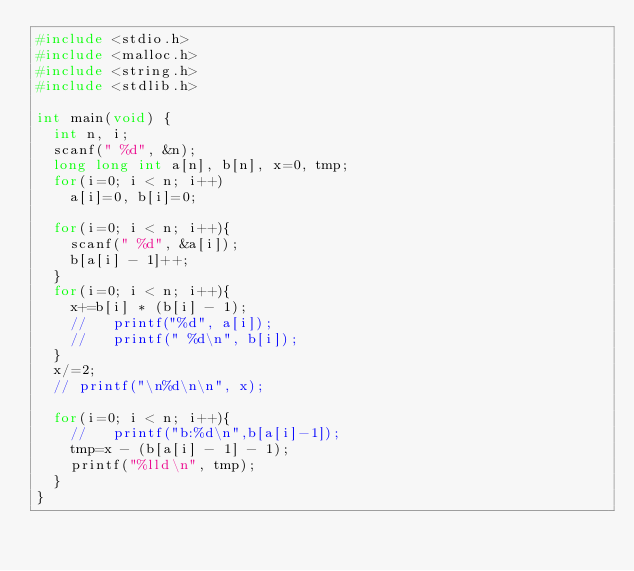Convert code to text. <code><loc_0><loc_0><loc_500><loc_500><_C_>#include <stdio.h>
#include <malloc.h>
#include <string.h>
#include <stdlib.h>

int main(void) {
  int n, i;
  scanf(" %d", &n);
  long long int a[n], b[n], x=0, tmp;
  for(i=0; i < n; i++)
    a[i]=0, b[i]=0;

  for(i=0; i < n; i++){
    scanf(" %d", &a[i]);
    b[a[i] - 1]++;
  }
  for(i=0; i < n; i++){
    x+=b[i] * (b[i] - 1);
    //   printf("%d", a[i]);
    //   printf(" %d\n", b[i]);
  }
  x/=2;
  // printf("\n%d\n\n", x);

  for(i=0; i < n; i++){
    //   printf("b:%d\n",b[a[i]-1]);
    tmp=x - (b[a[i] - 1] - 1);
    printf("%lld\n", tmp);
  }
}

</code> 